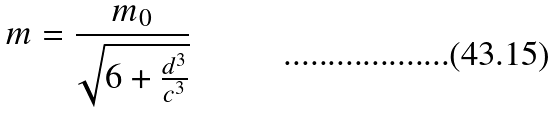Convert formula to latex. <formula><loc_0><loc_0><loc_500><loc_500>m = \frac { m _ { 0 } } { \sqrt { 6 + \frac { d ^ { 3 } } { c ^ { 3 } } } }</formula> 